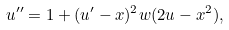<formula> <loc_0><loc_0><loc_500><loc_500>u ^ { \prime \prime } = 1 + ( u ^ { \prime } - x ) ^ { 2 } w ( 2 u - x ^ { 2 } ) ,</formula> 